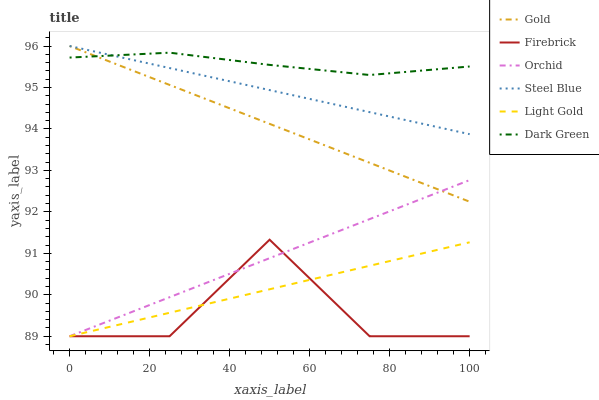Does Firebrick have the minimum area under the curve?
Answer yes or no. Yes. Does Dark Green have the maximum area under the curve?
Answer yes or no. Yes. Does Steel Blue have the minimum area under the curve?
Answer yes or no. No. Does Steel Blue have the maximum area under the curve?
Answer yes or no. No. Is Light Gold the smoothest?
Answer yes or no. Yes. Is Firebrick the roughest?
Answer yes or no. Yes. Is Steel Blue the smoothest?
Answer yes or no. No. Is Steel Blue the roughest?
Answer yes or no. No. Does Firebrick have the lowest value?
Answer yes or no. Yes. Does Steel Blue have the lowest value?
Answer yes or no. No. Does Steel Blue have the highest value?
Answer yes or no. Yes. Does Firebrick have the highest value?
Answer yes or no. No. Is Firebrick less than Steel Blue?
Answer yes or no. Yes. Is Gold greater than Light Gold?
Answer yes or no. Yes. Does Orchid intersect Gold?
Answer yes or no. Yes. Is Orchid less than Gold?
Answer yes or no. No. Is Orchid greater than Gold?
Answer yes or no. No. Does Firebrick intersect Steel Blue?
Answer yes or no. No. 